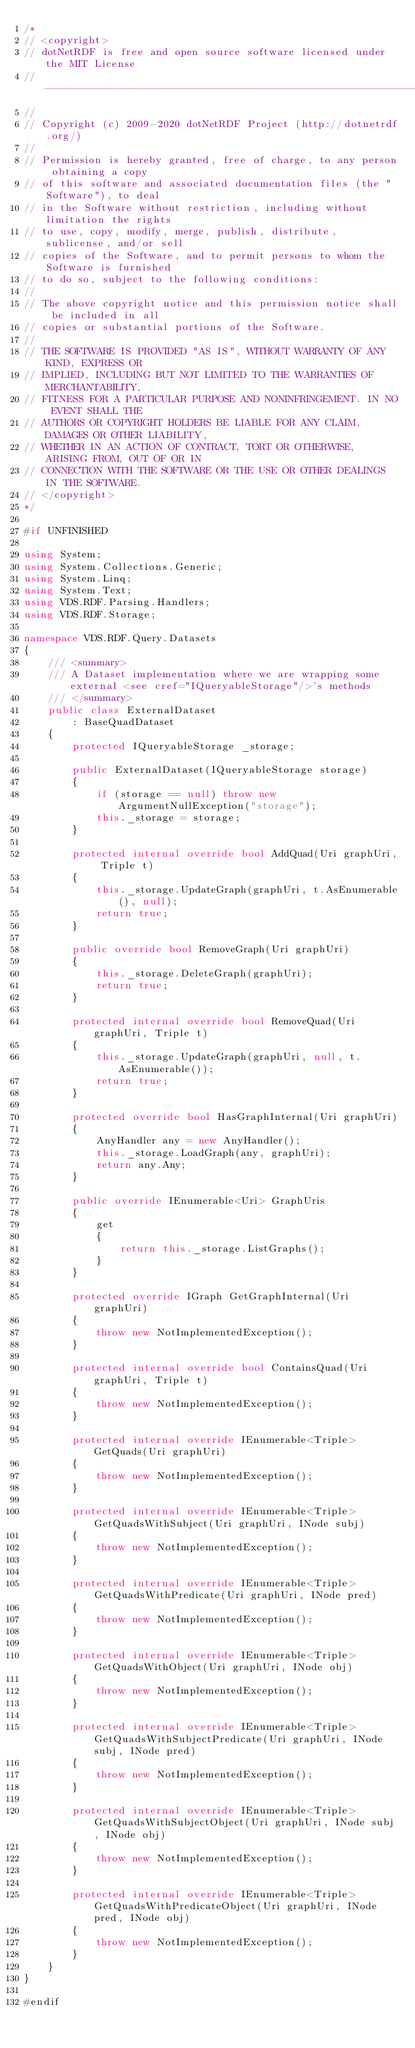Convert code to text. <code><loc_0><loc_0><loc_500><loc_500><_C#_>/*
// <copyright>
// dotNetRDF is free and open source software licensed under the MIT License
// -------------------------------------------------------------------------
// 
// Copyright (c) 2009-2020 dotNetRDF Project (http://dotnetrdf.org/)
// 
// Permission is hereby granted, free of charge, to any person obtaining a copy
// of this software and associated documentation files (the "Software"), to deal
// in the Software without restriction, including without limitation the rights
// to use, copy, modify, merge, publish, distribute, sublicense, and/or sell
// copies of the Software, and to permit persons to whom the Software is furnished
// to do so, subject to the following conditions:
// 
// The above copyright notice and this permission notice shall be included in all
// copies or substantial portions of the Software.
// 
// THE SOFTWARE IS PROVIDED "AS IS", WITHOUT WARRANTY OF ANY KIND, EXPRESS OR 
// IMPLIED, INCLUDING BUT NOT LIMITED TO THE WARRANTIES OF MERCHANTABILITY, 
// FITNESS FOR A PARTICULAR PURPOSE AND NONINFRINGEMENT. IN NO EVENT SHALL THE
// AUTHORS OR COPYRIGHT HOLDERS BE LIABLE FOR ANY CLAIM, DAMAGES OR OTHER LIABILITY,
// WHETHER IN AN ACTION OF CONTRACT, TORT OR OTHERWISE, ARISING FROM, OUT OF OR IN
// CONNECTION WITH THE SOFTWARE OR THE USE OR OTHER DEALINGS IN THE SOFTWARE.
// </copyright>
*/

#if UNFINISHED

using System;
using System.Collections.Generic;
using System.Linq;
using System.Text;
using VDS.RDF.Parsing.Handlers;
using VDS.RDF.Storage;

namespace VDS.RDF.Query.Datasets
{
    /// <summary>
    /// A Dataset implementation where we are wrapping some external <see cref="IQueryableStorage"/>'s methods
    /// </summary>
    public class ExternalDataset
        : BaseQuadDataset
    {
        protected IQueryableStorage _storage;

        public ExternalDataset(IQueryableStorage storage)
        {
            if (storage == null) throw new ArgumentNullException("storage");
            this._storage = storage;
        }

        protected internal override bool AddQuad(Uri graphUri, Triple t)
        {
            this._storage.UpdateGraph(graphUri, t.AsEnumerable(), null);
            return true;
        }

        public override bool RemoveGraph(Uri graphUri)
        {
            this._storage.DeleteGraph(graphUri);
            return true;
        }

        protected internal override bool RemoveQuad(Uri graphUri, Triple t)
        {
            this._storage.UpdateGraph(graphUri, null, t.AsEnumerable());
            return true;
        }

        protected override bool HasGraphInternal(Uri graphUri)
        {
            AnyHandler any = new AnyHandler();
            this._storage.LoadGraph(any, graphUri);
            return any.Any;
        }

        public override IEnumerable<Uri> GraphUris
        {
            get 
            {
                return this._storage.ListGraphs();
            }
        }

        protected override IGraph GetGraphInternal(Uri graphUri)
        {
            throw new NotImplementedException();
        }

        protected internal override bool ContainsQuad(Uri graphUri, Triple t)
        {
            throw new NotImplementedException();
        }

        protected internal override IEnumerable<Triple> GetQuads(Uri graphUri)
        {
            throw new NotImplementedException();
        }

        protected internal override IEnumerable<Triple> GetQuadsWithSubject(Uri graphUri, INode subj)
        {
            throw new NotImplementedException();
        }

        protected internal override IEnumerable<Triple> GetQuadsWithPredicate(Uri graphUri, INode pred)
        {
            throw new NotImplementedException();
        }

        protected internal override IEnumerable<Triple> GetQuadsWithObject(Uri graphUri, INode obj)
        {
            throw new NotImplementedException();
        }

        protected internal override IEnumerable<Triple> GetQuadsWithSubjectPredicate(Uri graphUri, INode subj, INode pred)
        {
            throw new NotImplementedException();
        }

        protected internal override IEnumerable<Triple> GetQuadsWithSubjectObject(Uri graphUri, INode subj, INode obj)
        {
            throw new NotImplementedException();
        }

        protected internal override IEnumerable<Triple> GetQuadsWithPredicateObject(Uri graphUri, INode pred, INode obj)
        {
            throw new NotImplementedException();
        }
    }
}

#endif</code> 